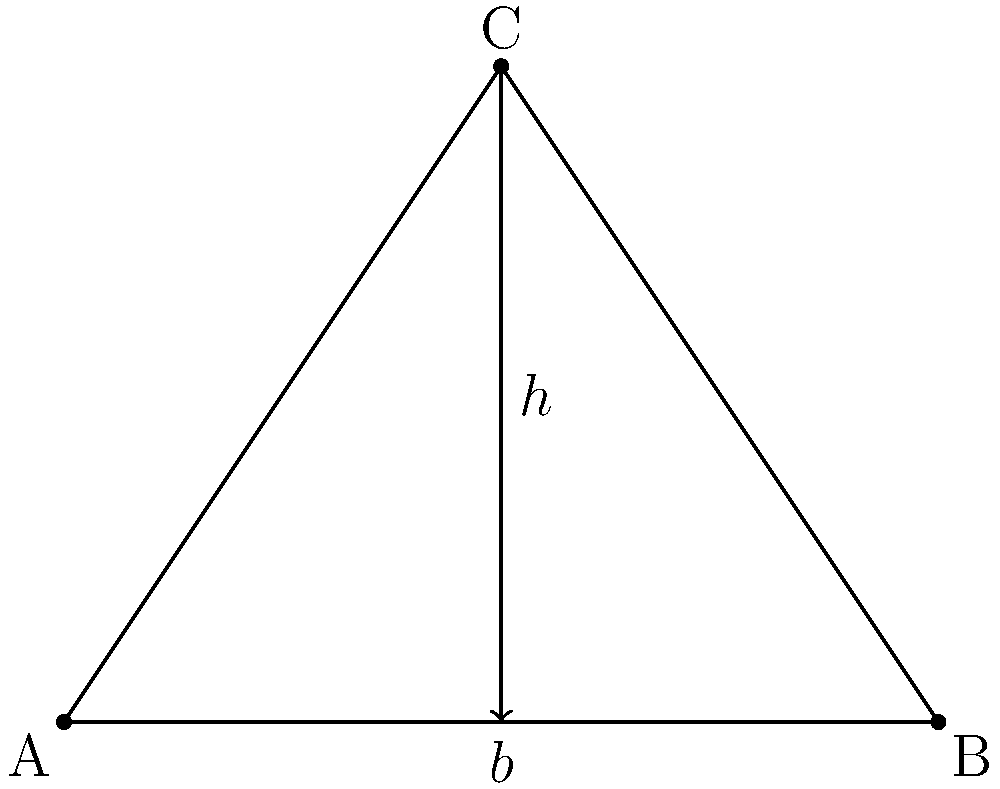In a 17th-century scientific diagram found in the archives of an early research institute, a triangle ABC is used to illustrate a principle of optics. The height (h) of the triangle is 3 units, and its base (b) is 4 units. If the area of this triangle represents the spread of scientific knowledge in the local community, what is the ratio of the triangle's area to the square of its base? How might this ratio have been interpreted in terms of the institute's educational impact? Let's approach this step-by-step:

1) First, we need to calculate the area of the triangle. The formula for the area of a triangle is:

   $$ A = \frac{1}{2} \times base \times height $$

2) We're given that the base (b) is 4 units and the height (h) is 3 units. Let's substitute these values:

   $$ A = \frac{1}{2} \times 4 \times 3 = 6 \text{ square units} $$

3) Now, we need to calculate the square of the base:

   $$ b^2 = 4^2 = 16 \text{ square units} $$

4) The question asks for the ratio of the triangle's area to the square of its base. This can be expressed as:

   $$ \text{Ratio} = \frac{A}{b^2} = \frac{6}{16} = \frac{3}{8} = 0.375 $$

5) To simplify this fraction, we can divide both numerator and denominator by their greatest common divisor (GCD), which is 1 in this case. So, the simplified ratio is 3:8.

Interpretation: This ratio (3:8 or 0.375) could be interpreted as a measure of the institute's educational efficiency. It shows that the spread of knowledge (represented by the triangle's area) is 37.5% of the maximum potential spread (represented by the square of the base). In the context of the 17th century, this might have been considered a significant impact, given the limited resources and communication methods of the time.
Answer: 3:8 